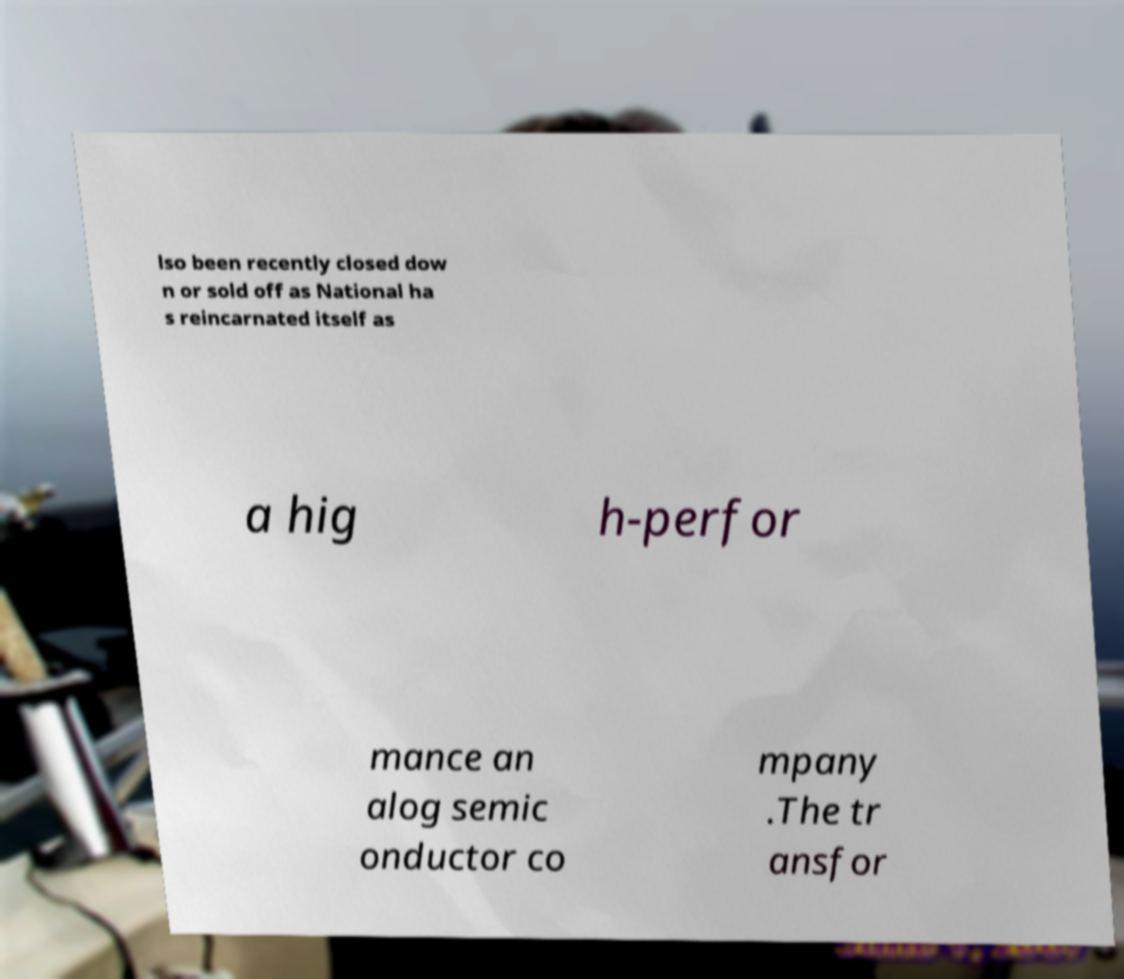I need the written content from this picture converted into text. Can you do that? lso been recently closed dow n or sold off as National ha s reincarnated itself as a hig h-perfor mance an alog semic onductor co mpany .The tr ansfor 